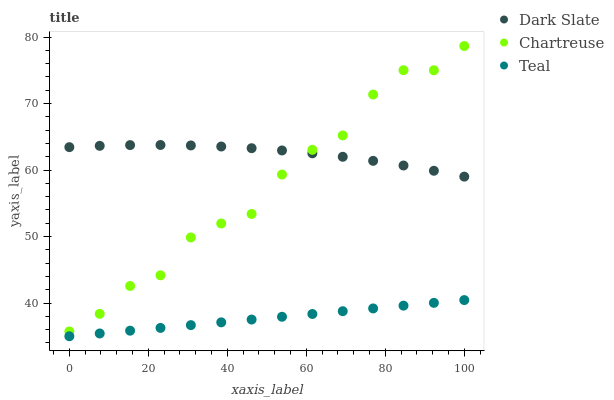Does Teal have the minimum area under the curve?
Answer yes or no. Yes. Does Dark Slate have the maximum area under the curve?
Answer yes or no. Yes. Does Chartreuse have the minimum area under the curve?
Answer yes or no. No. Does Chartreuse have the maximum area under the curve?
Answer yes or no. No. Is Teal the smoothest?
Answer yes or no. Yes. Is Chartreuse the roughest?
Answer yes or no. Yes. Is Chartreuse the smoothest?
Answer yes or no. No. Is Teal the roughest?
Answer yes or no. No. Does Teal have the lowest value?
Answer yes or no. Yes. Does Chartreuse have the lowest value?
Answer yes or no. No. Does Chartreuse have the highest value?
Answer yes or no. Yes. Does Teal have the highest value?
Answer yes or no. No. Is Teal less than Dark Slate?
Answer yes or no. Yes. Is Chartreuse greater than Teal?
Answer yes or no. Yes. Does Chartreuse intersect Dark Slate?
Answer yes or no. Yes. Is Chartreuse less than Dark Slate?
Answer yes or no. No. Is Chartreuse greater than Dark Slate?
Answer yes or no. No. Does Teal intersect Dark Slate?
Answer yes or no. No. 